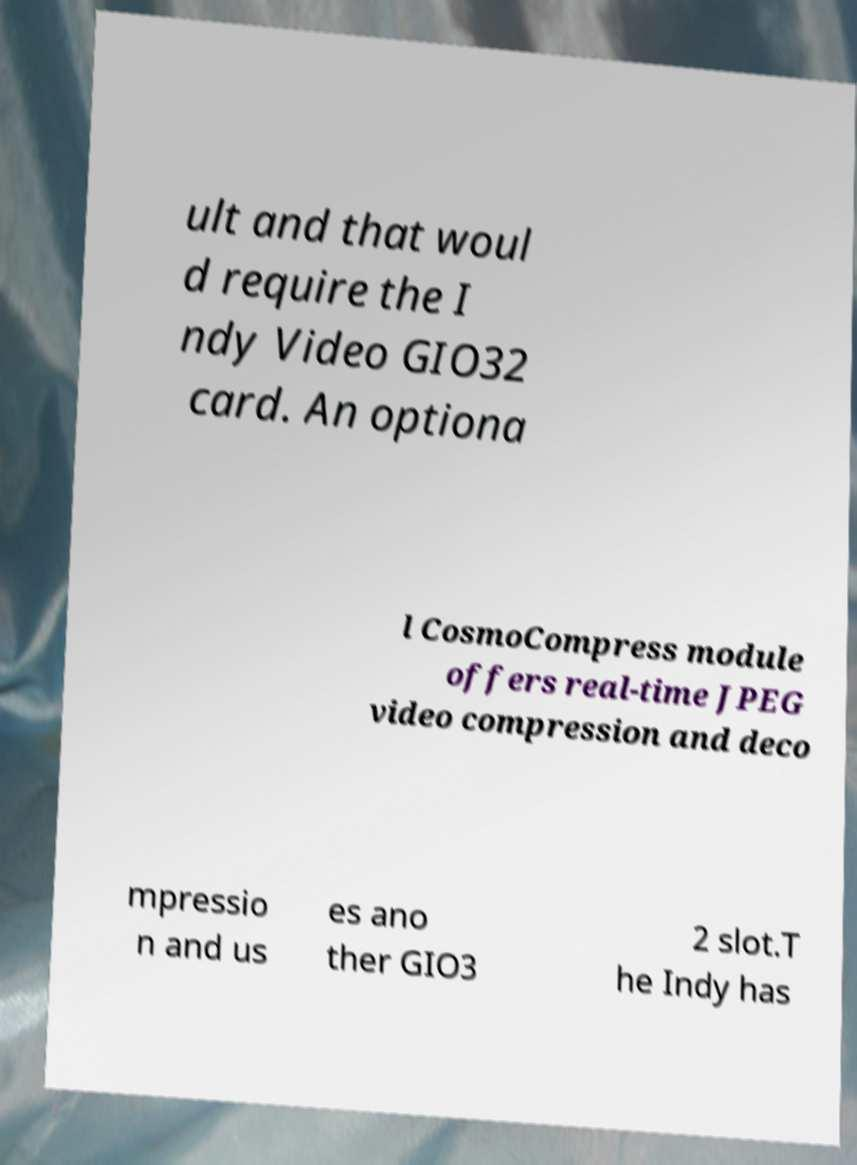Could you assist in decoding the text presented in this image and type it out clearly? ult and that woul d require the I ndy Video GIO32 card. An optiona l CosmoCompress module offers real-time JPEG video compression and deco mpressio n and us es ano ther GIO3 2 slot.T he Indy has 